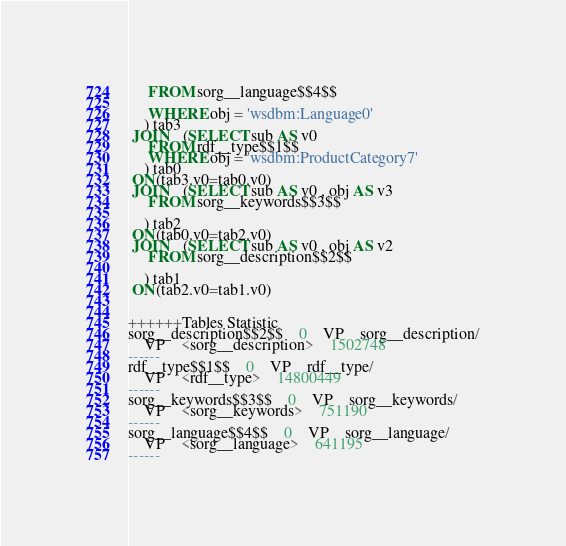<code> <loc_0><loc_0><loc_500><loc_500><_SQL_>	 FROM sorg__language$$4$$
	 
	 WHERE obj = 'wsdbm:Language0'
	) tab3
 JOIN    (SELECT sub AS v0 
	 FROM rdf__type$$1$$ 
	 WHERE obj = 'wsdbm:ProductCategory7'
	) tab0
 ON(tab3.v0=tab0.v0)
 JOIN    (SELECT sub AS v0 , obj AS v3 
	 FROM sorg__keywords$$3$$
	
	) tab2
 ON(tab0.v0=tab2.v0)
 JOIN    (SELECT sub AS v0 , obj AS v2 
	 FROM sorg__description$$2$$
	
	) tab1
 ON(tab2.v0=tab1.v0)


++++++Tables Statistic
sorg__description$$2$$	0	VP	sorg__description/
	VP	<sorg__description>	1502748
------
rdf__type$$1$$	0	VP	rdf__type/
	VP	<rdf__type>	14800449
------
sorg__keywords$$3$$	0	VP	sorg__keywords/
	VP	<sorg__keywords>	751190
------
sorg__language$$4$$	0	VP	sorg__language/
	VP	<sorg__language>	641195
------
</code> 